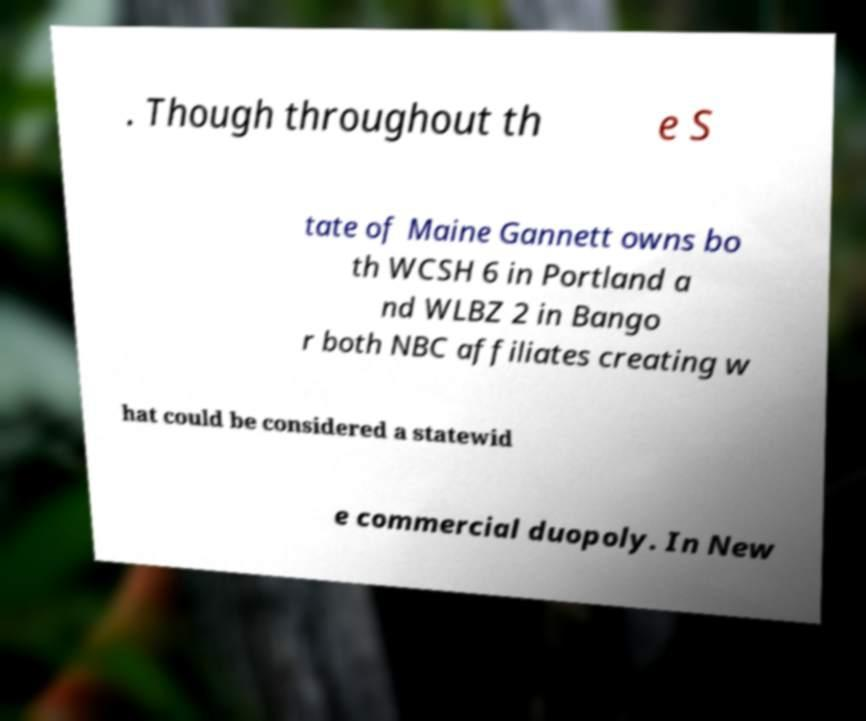Could you assist in decoding the text presented in this image and type it out clearly? . Though throughout th e S tate of Maine Gannett owns bo th WCSH 6 in Portland a nd WLBZ 2 in Bango r both NBC affiliates creating w hat could be considered a statewid e commercial duopoly. In New 